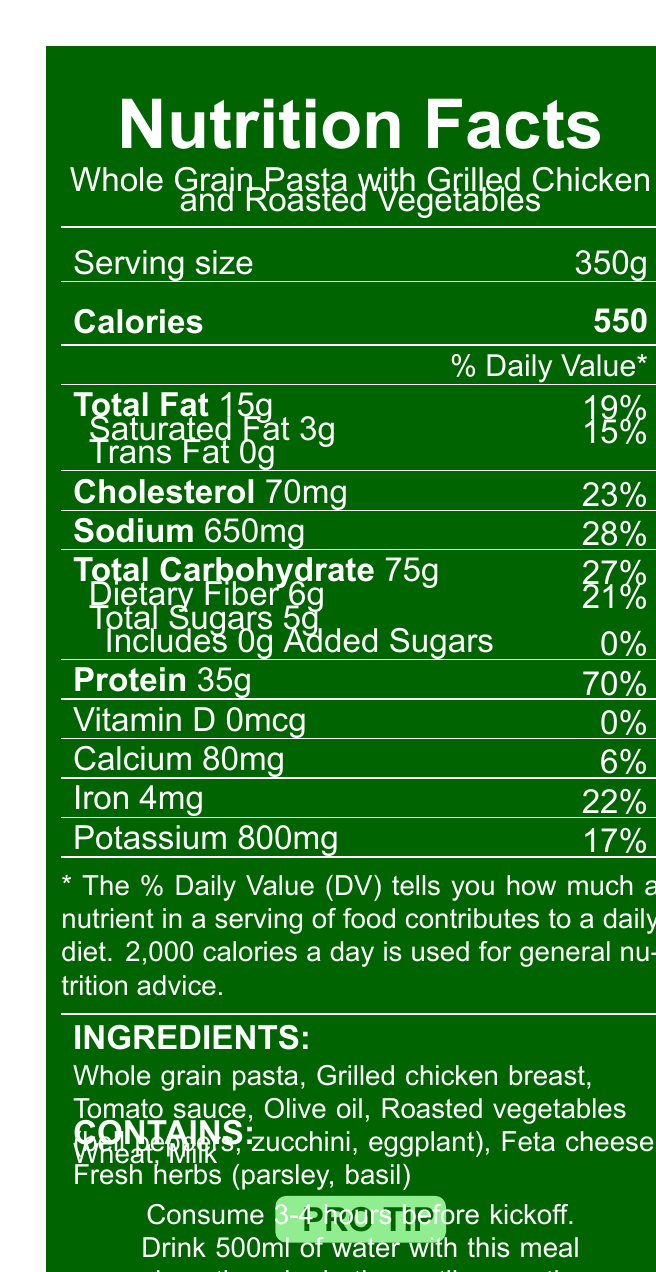What is the serving size of the meal? The serving size is explicitly mentioned in the document as "Serving size: 350g."
Answer: 350g How many calories does one serving contain? The document states "Calories: 550."
Answer: 550 What percentage of the daily value of protein does this meal provide? The document states "Protein 35g (70% DV)."
Answer: 70% Does this meal contain any trans fat? The nutrition facts include "Trans Fat: 0g," indicating there is no trans fat.
Answer: No What is the main benefit of consuming this meal before a game? The special notes mention it is high in complex carbohydrates for sustained energy, has lean protein for muscle recovery, and is rich in antioxidants from vegetables.
Answer: Sustained energy, muscle recovery, rich in antioxidants Which ingredient contributes to the calcium content? A. Whole grain pasta B. Tomato sauce C. Feta cheese D. Olive oil Feta cheese is likely to contribute to the calcium content; it is listed as an ingredient.
Answer: C What are the allergens present in this meal? 1. Dairy 2. Nuts 3. Wheat 4. Soy The document lists Wheat and Milk under allergens.
Answer: 1 and 3 True or False: This meal is low in sodium. The meal contains 650mg of sodium, which is 28% of the daily value, considered moderate to high.
Answer: False Summarize the key nutritional benefits of this pre-game meal. The summary covers the main aspects mentioned in the special notes, including the recommended timing and hydration tips.
Answer: The pre-game meal is high in complex carbohydrates for sustained energy, contains lean protein for muscle recovery, provides antioxidants from vegetables, has moderate sodium content for electrolyte balance, low in added sugars, and includes omega-3 fatty acids from olive oil. It is recommended to consume 3-4 hours before kickoff with ample hydration. What are the macronutrients provided by this meal? The macronutrients listed in the document are Total Fat (15g), Saturated Fat (3g), Total Carbohydrate (75g), Dietary Fiber (6g), Total Sugars (5g), and Protein (35g).
Answer: Total Fat, Saturated Fat, Total Carbohydrate, Dietary Fiber, Total Sugars, Protein How much dietary fiber is in one serving of this meal? The document lists "Dietary Fiber: 6g."
Answer: 6g What percentage of the daily value of iron does this meal provide? The document states "Iron 4mg (22% DV)."
Answer: 22% How much sodium does the meal contain? The document mentions "Sodium: 650mg."
Answer: 650mg Can you determine the exact brand of the whole grain pasta used in this meal? The document only lists "Whole grain pasta" as an ingredient without specifying the brand.
Answer: Not enough information 